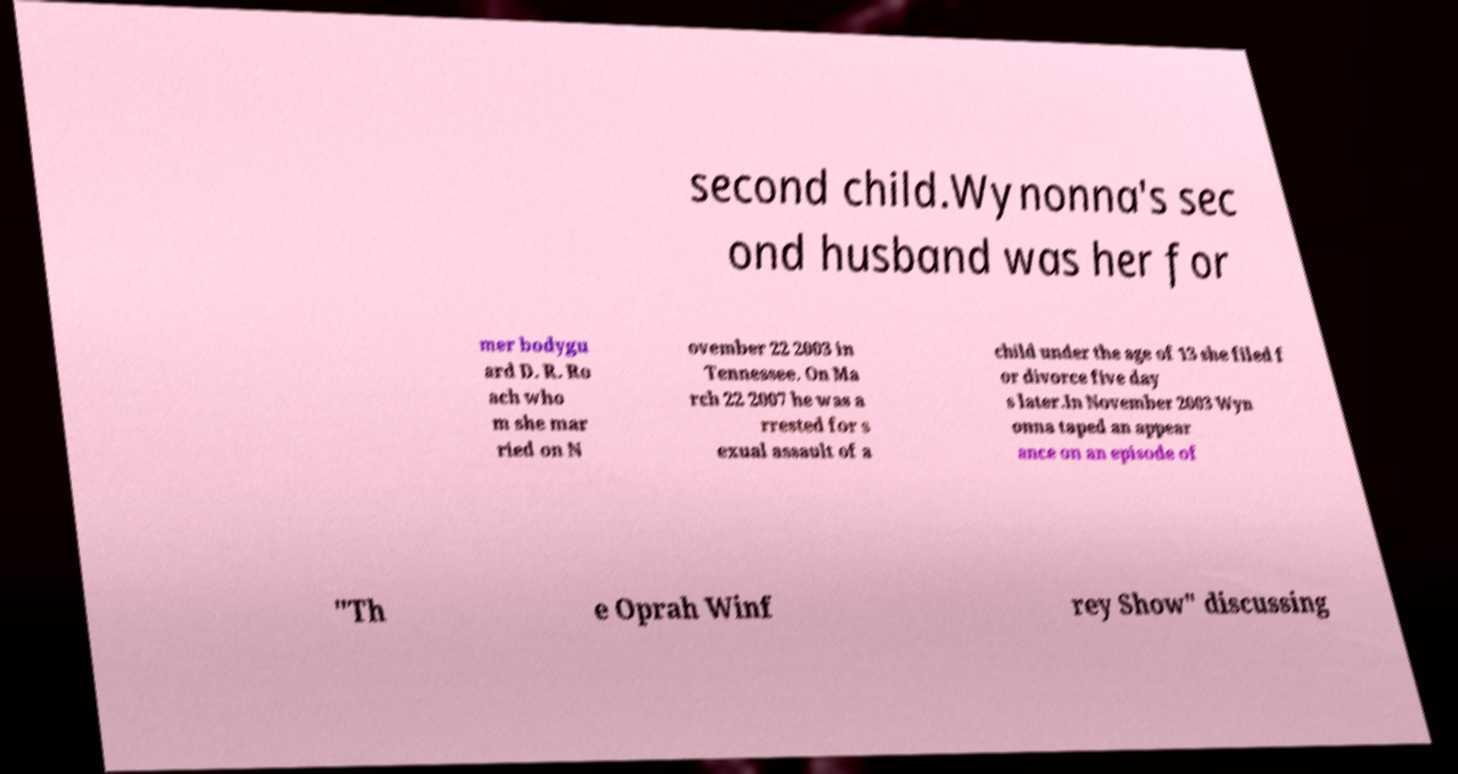There's text embedded in this image that I need extracted. Can you transcribe it verbatim? second child.Wynonna's sec ond husband was her for mer bodygu ard D. R. Ro ach who m she mar ried on N ovember 22 2003 in Tennessee. On Ma rch 22 2007 he was a rrested for s exual assault of a child under the age of 13 she filed f or divorce five day s later.In November 2003 Wyn onna taped an appear ance on an episode of "Th e Oprah Winf rey Show" discussing 